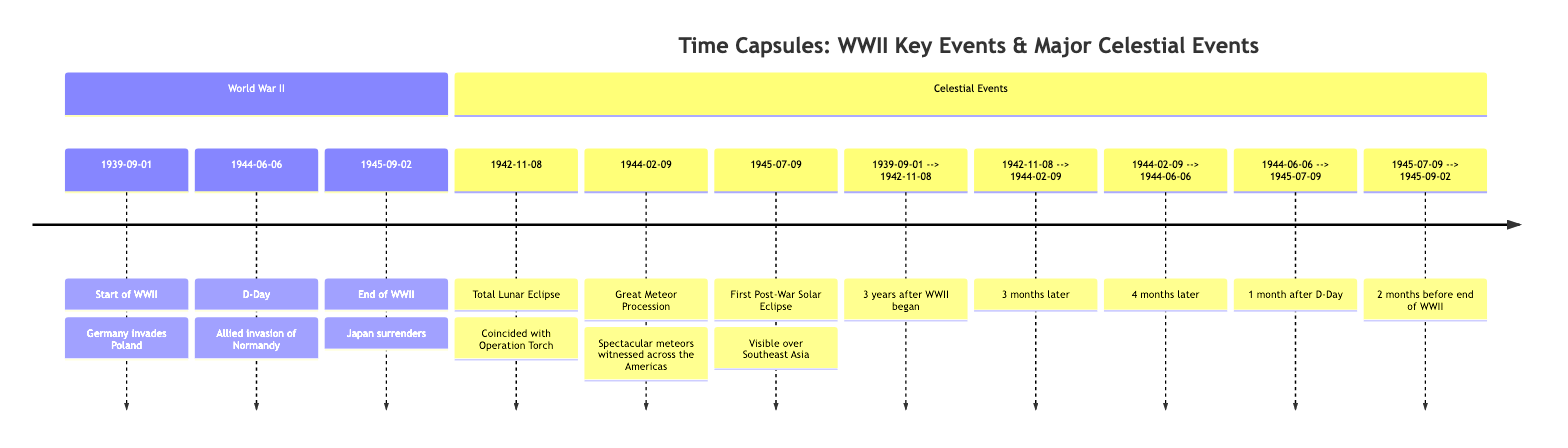What event marks the start of WWII? According to the diagram, the event that marks the start of WWII is the German invasion of Poland on September 1, 1939.
Answer: German invasion of Poland How many celestial events are listed in the diagram? The diagram lists three celestial events: the total lunar eclipse in 1942, the great meteor procession in 1944, and the first post-war solar eclipse in 1945. Hence, the total is three events.
Answer: 3 What date does the D-Day event occur? In the diagram, the D-Day event, which is the Allied invasion of Normandy, occurs on June 6, 1944.
Answer: June 6, 1944 What event is connected to D-Day? The diagram shows that a solar eclipse, occurring on July 9, 1945, is connected to D-Day, as it is noted to be one month after this significant WWII event.
Answer: First Post-War Solar Eclipse How many months elapsed between the start of WWII and the total lunar eclipse? The diagram indicates that the total lunar eclipse occurred on November 8, 1942, which is three years after the start of WWII on September 1, 1939. Therefore, the number of months is calculated to be 36 months.
Answer: 36 months Which celestial event occurred closest to the end of WWII? From the diagram, the first post-war solar eclipse on July 9, 1945, occurred closest to the end of WWII, which took place on September 2, 1945, just two months before that date.
Answer: First Post-War Solar Eclipse What is the relationship between the great meteor procession and D-Day? The diagram shows that the great meteor procession occurred on February 9, 1944, which is four months prior to the D-Day event on June 6, 1944. This indicates the relationship is that the meteor procession happened before D-Day by four months.
Answer: 4 months before What key WWII event occurred just before the first post-war solar eclipse? According to the diagram, the last key WWII event before the first post-war solar eclipse was the end of WWII, which happened on September 2, 1945. The eclipse occurred two months prior to this date.
Answer: End of WWII What is the date of the great meteor procession? The diagram states that the great meteor procession took place on February 9, 1944.
Answer: February 9, 1944 